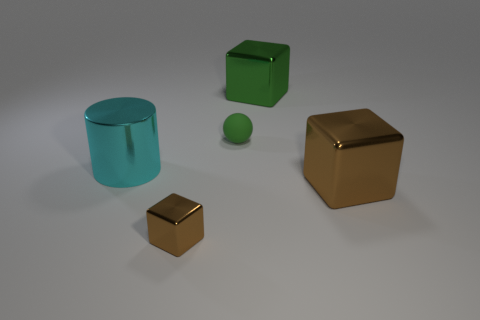Does the small shiny object have the same color as the small sphere?
Provide a short and direct response. No. There is a big green object that is the same shape as the small brown thing; what is its material?
Offer a very short reply. Metal. Is there any other thing that is made of the same material as the cylinder?
Make the answer very short. Yes. Is the number of big green blocks behind the cylinder the same as the number of large metal blocks that are on the left side of the green rubber sphere?
Provide a short and direct response. No. Do the green ball and the large cylinder have the same material?
Your answer should be very brief. No. What number of purple things are tiny shiny blocks or blocks?
Keep it short and to the point. 0. What number of tiny rubber things are the same shape as the big brown metallic object?
Offer a terse response. 0. What is the cyan cylinder made of?
Give a very brief answer. Metal. Are there the same number of big shiny cubes on the left side of the tiny shiny cube and big spheres?
Your answer should be very brief. Yes. The cyan object that is the same size as the green cube is what shape?
Offer a terse response. Cylinder. 